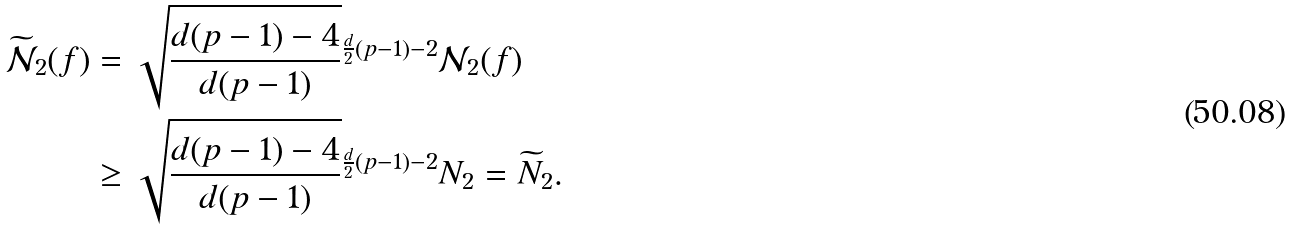<formula> <loc_0><loc_0><loc_500><loc_500>\widetilde { \mathcal { N } } _ { 2 } ( f ) & = \sqrt { \frac { d ( p - 1 ) - 4 } { d ( p - 1 ) } } ^ { \frac { d } { 2 } ( p - 1 ) - 2 } \mathcal { N } _ { 2 } ( f ) \\ & \geq \sqrt { \frac { d ( p - 1 ) - 4 } { d ( p - 1 ) } } ^ { \frac { d } { 2 } ( p - 1 ) - 2 } N _ { 2 } = \widetilde { N } _ { 2 } .</formula> 